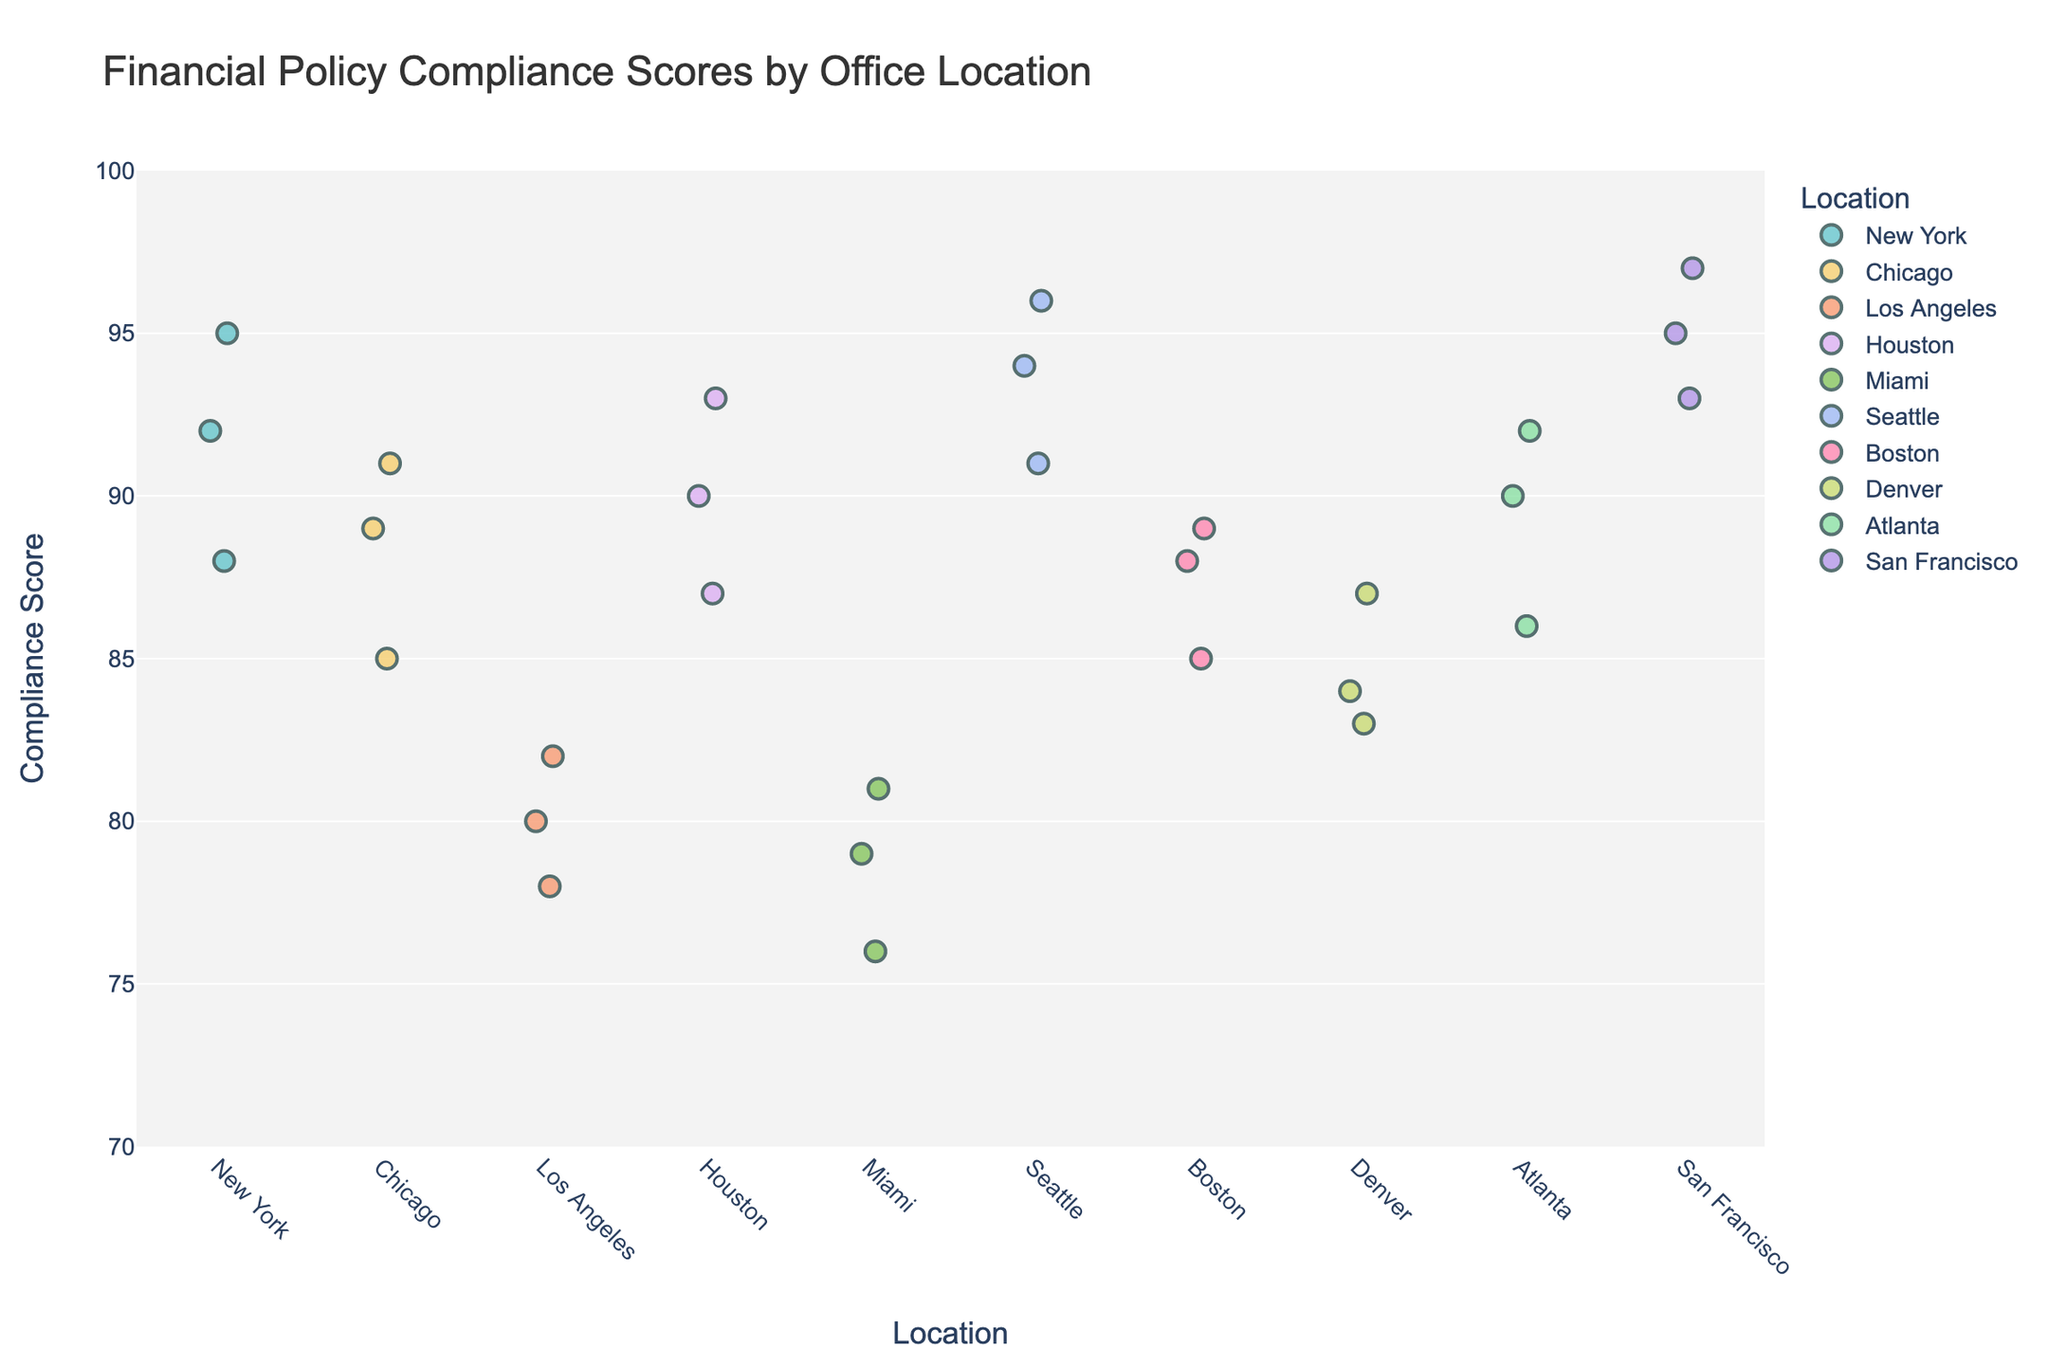What is the title of the plot? The title is located at the top of the plot and is typically larger and more prominent than other text. Observing the figure, we can identify the title directly.
Answer: Financial Policy Compliance Scores by Office Location How many locations are represented in the plot? By looking at the x-axis of the figure, which lists the names of each location, we can count the distinct number of office locations.
Answer: 10 Which location has the highest compliance score? Identifying the highest point on the y-axis and then checking the corresponding location on the x-axis helps determine which location has the highest compliance score.
Answer: San Francisco What is the range of compliance scores for Miami? The range is calculated by subtracting the lowest score from the highest score for Miami on the y-axis. Observing the plot, Miami's scores range between 76 and 81.
Answer: 5 Which locations have a compliance score greater than 90? By examining the points above the y-axis value of 90 and noting the corresponding x-axis locations, we find which locations meet the criteria.
Answer: New York, Houston, Seattle, Atlanta, San Francisco What is the median compliance score for Boston? To find the median, we list Boston's scores (88, 85, 89) and select the middle value since there is an odd number of points.
Answer: 88 Between Chicago and Denver, which location has a higher average compliance score? Calculate the average for both locations: Chicago's scores (85, 89, 91) average to (85+89+91)/3 = 88.33, and Denver's scores (83, 87, 84) average to (83+87+84)/3 = 84.67. Comparing these averages shows Chicago has a higher average.
Answer: Chicago What is the difference in compliance scores between the highest point in Los Angeles and the lowest point in New York? The highest score in Los Angeles is 82, and the lowest in New York is 88. Subtracting these gives: 88 - 78 = 10.
Answer: 10 How many data points are there for each location? Each location is represented by exactly three points, as observed from the uniform distribution of points across the x-axis locations.
Answer: 3 Which location has the smallest variation in compliance scores? Variation is measured by the range of scores. By observing the differences between the highest and lowest points for each location, we determine Seattle (96-91=5) has one of the smallest variations. Multiple locations could have the same variation, so further check might reveal more such locations but based on a quick glance, Seattle stands out.
Answer: Seattle 